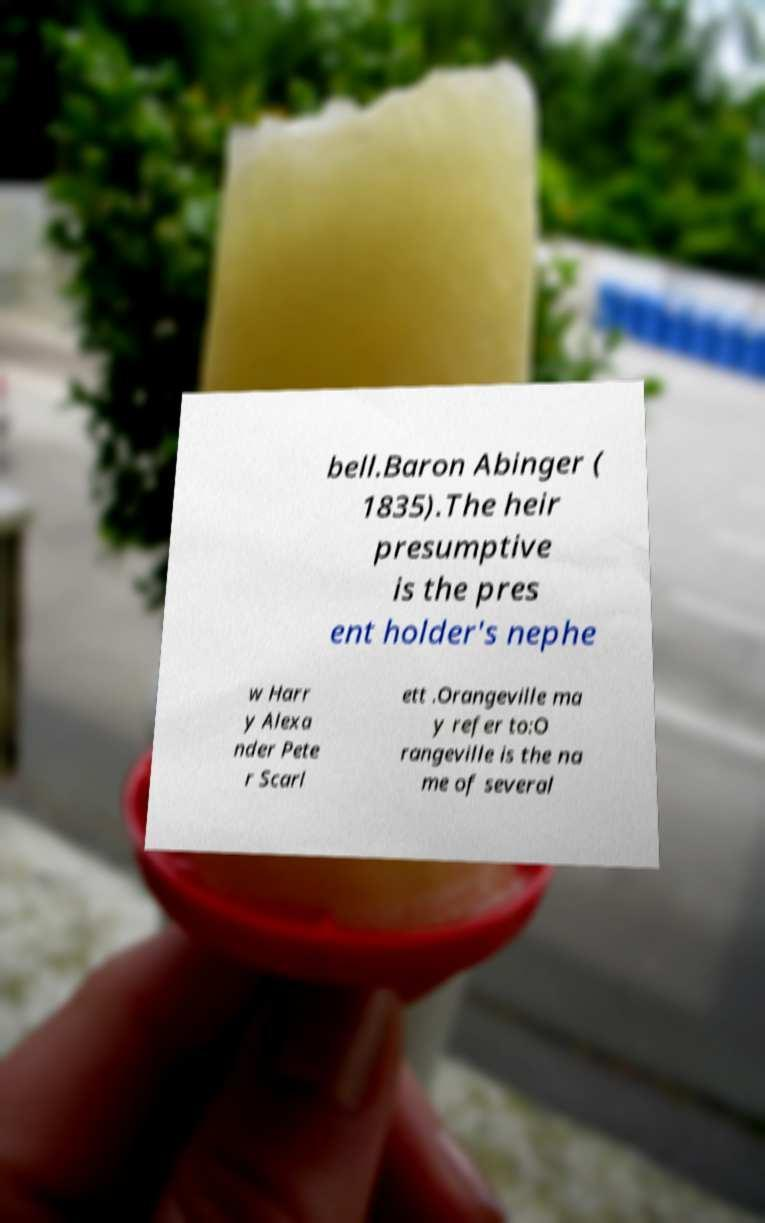Could you assist in decoding the text presented in this image and type it out clearly? bell.Baron Abinger ( 1835).The heir presumptive is the pres ent holder's nephe w Harr y Alexa nder Pete r Scarl ett .Orangeville ma y refer to:O rangeville is the na me of several 